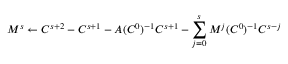<formula> <loc_0><loc_0><loc_500><loc_500>M ^ { s } \gets C ^ { s + 2 } - C ^ { s + 1 } - A ( C ^ { 0 } ) ^ { - 1 } C ^ { s + 1 } - \sum _ { j = 0 } ^ { s } M ^ { j } ( C ^ { 0 } ) ^ { - 1 } C ^ { s - j }</formula> 